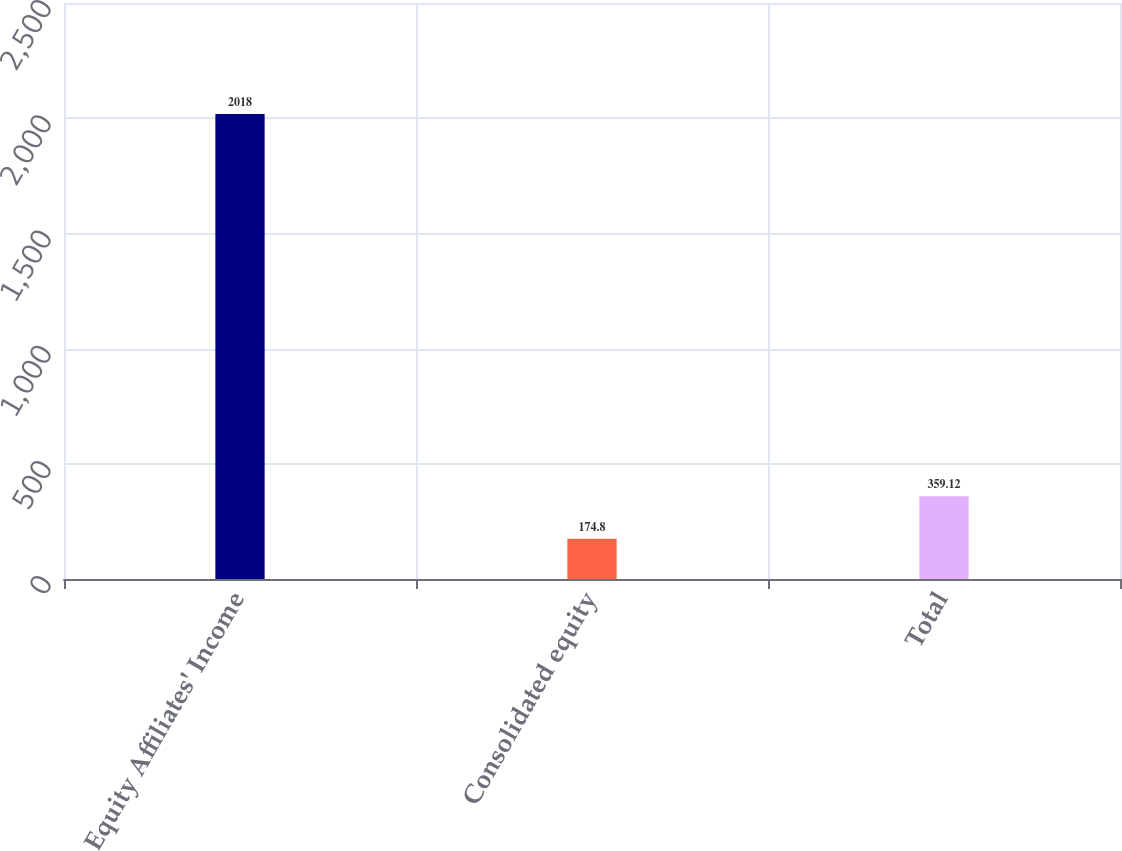<chart> <loc_0><loc_0><loc_500><loc_500><bar_chart><fcel>Equity Affiliates' Income<fcel>Consolidated equity<fcel>Total<nl><fcel>2018<fcel>174.8<fcel>359.12<nl></chart> 